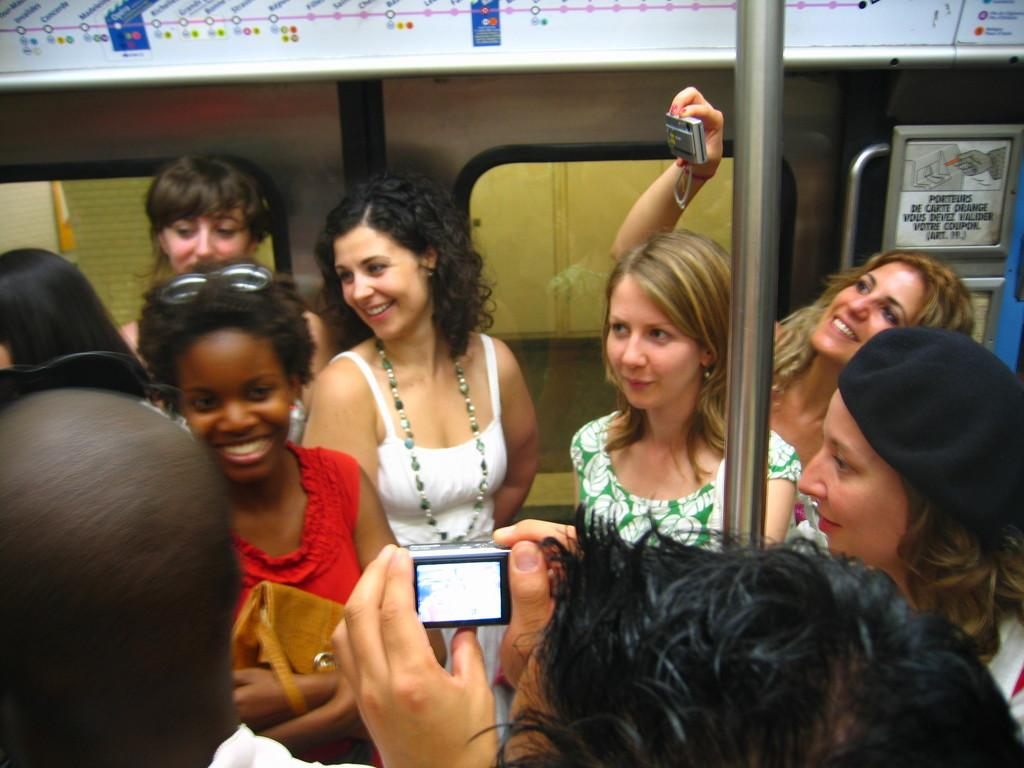What is the main subject of the image? The main subject of the image is a group of people. Where are the people located in the image? The group of people is in the front. What else can be seen in the image besides the people? There is a train in the image. What are two people in the group doing? Two people in the group are holding cameras. What type of animals can be seen at the zoo in the image? There is no zoo present in the image, so it is not possible to determine what type of animals might be seen there. 